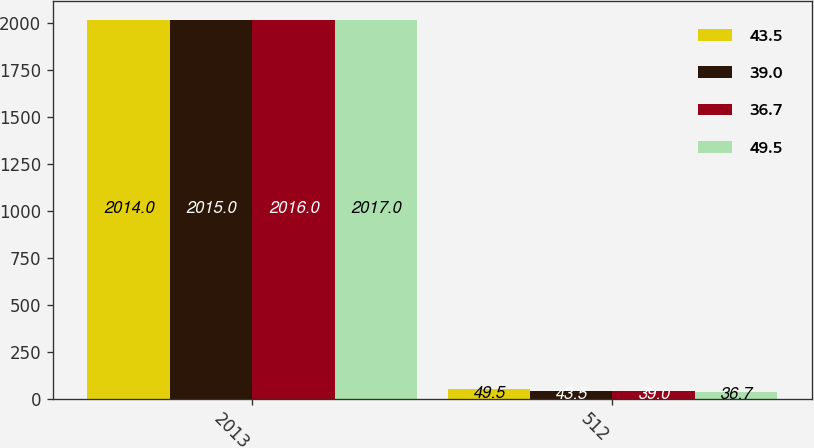<chart> <loc_0><loc_0><loc_500><loc_500><stacked_bar_chart><ecel><fcel>2013<fcel>512<nl><fcel>43.5<fcel>2014<fcel>49.5<nl><fcel>39<fcel>2015<fcel>43.5<nl><fcel>36.7<fcel>2016<fcel>39<nl><fcel>49.5<fcel>2017<fcel>36.7<nl></chart> 